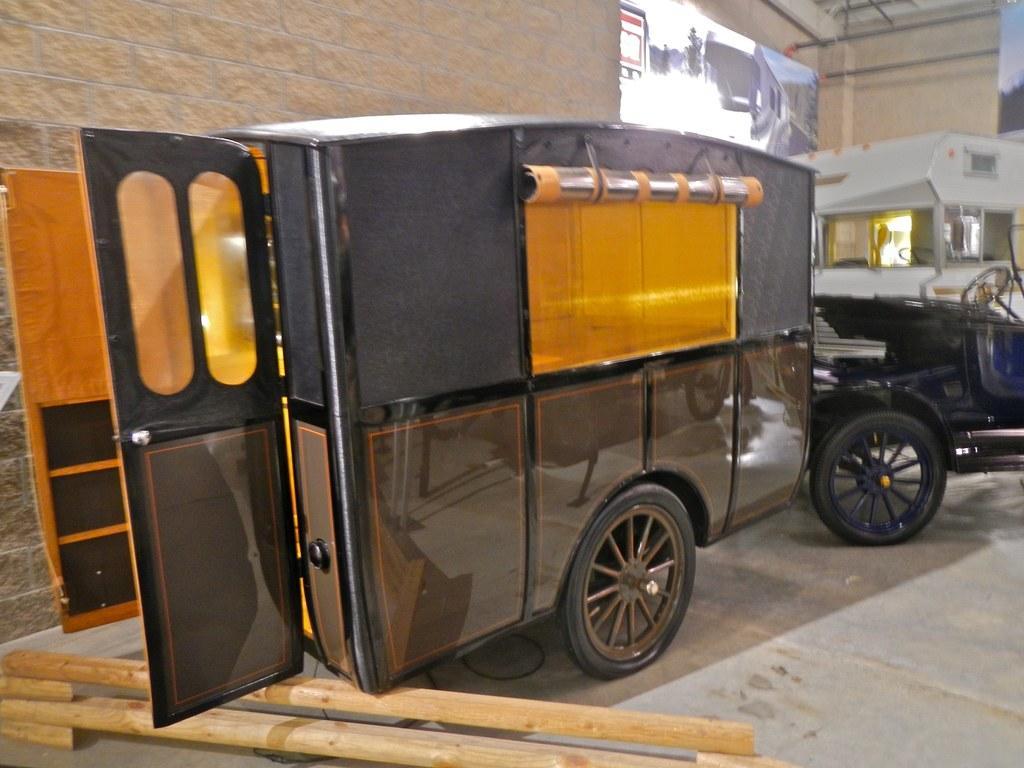Describe this image in one or two sentences. In this image we can see a few vehicles, there is some wood on the floor and also we can see the wall and other objects. 